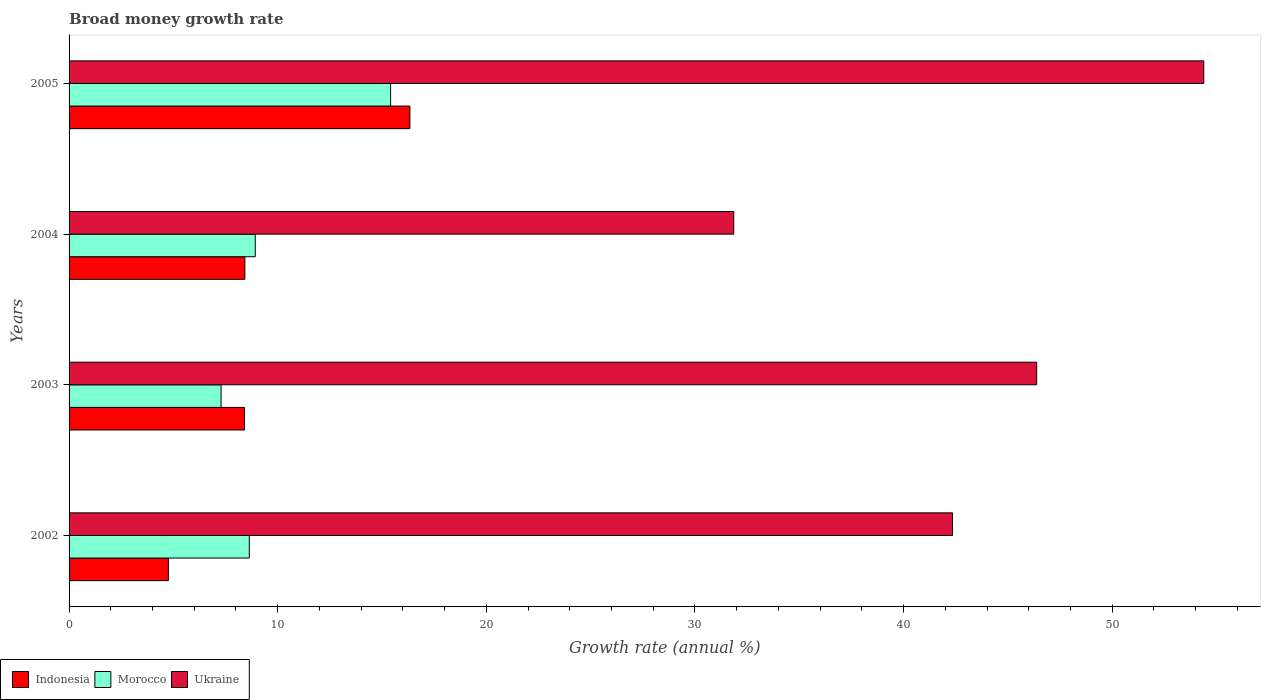Are the number of bars on each tick of the Y-axis equal?
Provide a short and direct response. Yes. What is the label of the 3rd group of bars from the top?
Offer a terse response. 2003. What is the growth rate in Ukraine in 2005?
Give a very brief answer. 54.39. Across all years, what is the maximum growth rate in Ukraine?
Keep it short and to the point. 54.39. Across all years, what is the minimum growth rate in Ukraine?
Your answer should be very brief. 31.86. In which year was the growth rate in Indonesia minimum?
Offer a terse response. 2002. What is the total growth rate in Indonesia in the graph?
Provide a succinct answer. 37.93. What is the difference between the growth rate in Morocco in 2003 and that in 2004?
Provide a succinct answer. -1.64. What is the difference between the growth rate in Morocco in 2004 and the growth rate in Indonesia in 2002?
Offer a very short reply. 4.16. What is the average growth rate in Ukraine per year?
Your answer should be very brief. 43.74. In the year 2002, what is the difference between the growth rate in Morocco and growth rate in Ukraine?
Provide a short and direct response. -33.7. In how many years, is the growth rate in Morocco greater than 30 %?
Offer a terse response. 0. What is the ratio of the growth rate in Indonesia in 2002 to that in 2003?
Provide a short and direct response. 0.57. What is the difference between the highest and the second highest growth rate in Indonesia?
Make the answer very short. 7.91. What is the difference between the highest and the lowest growth rate in Ukraine?
Offer a terse response. 22.53. What does the 1st bar from the top in 2004 represents?
Provide a succinct answer. Ukraine. What does the 1st bar from the bottom in 2002 represents?
Offer a very short reply. Indonesia. How many bars are there?
Make the answer very short. 12. Are all the bars in the graph horizontal?
Your response must be concise. Yes. What is the difference between two consecutive major ticks on the X-axis?
Provide a succinct answer. 10. Are the values on the major ticks of X-axis written in scientific E-notation?
Keep it short and to the point. No. Does the graph contain grids?
Your response must be concise. No. Where does the legend appear in the graph?
Ensure brevity in your answer.  Bottom left. How many legend labels are there?
Make the answer very short. 3. What is the title of the graph?
Ensure brevity in your answer.  Broad money growth rate. What is the label or title of the X-axis?
Give a very brief answer. Growth rate (annual %). What is the label or title of the Y-axis?
Ensure brevity in your answer.  Years. What is the Growth rate (annual %) of Indonesia in 2002?
Your response must be concise. 4.76. What is the Growth rate (annual %) in Morocco in 2002?
Your answer should be compact. 8.64. What is the Growth rate (annual %) in Ukraine in 2002?
Your response must be concise. 42.34. What is the Growth rate (annual %) in Indonesia in 2003?
Your answer should be compact. 8.41. What is the Growth rate (annual %) in Morocco in 2003?
Make the answer very short. 7.29. What is the Growth rate (annual %) of Ukraine in 2003?
Your answer should be compact. 46.38. What is the Growth rate (annual %) in Indonesia in 2004?
Offer a very short reply. 8.43. What is the Growth rate (annual %) of Morocco in 2004?
Give a very brief answer. 8.92. What is the Growth rate (annual %) in Ukraine in 2004?
Your response must be concise. 31.86. What is the Growth rate (annual %) in Indonesia in 2005?
Give a very brief answer. 16.34. What is the Growth rate (annual %) of Morocco in 2005?
Ensure brevity in your answer.  15.41. What is the Growth rate (annual %) in Ukraine in 2005?
Your response must be concise. 54.39. Across all years, what is the maximum Growth rate (annual %) in Indonesia?
Offer a terse response. 16.34. Across all years, what is the maximum Growth rate (annual %) in Morocco?
Provide a short and direct response. 15.41. Across all years, what is the maximum Growth rate (annual %) of Ukraine?
Provide a succinct answer. 54.39. Across all years, what is the minimum Growth rate (annual %) of Indonesia?
Give a very brief answer. 4.76. Across all years, what is the minimum Growth rate (annual %) in Morocco?
Your response must be concise. 7.29. Across all years, what is the minimum Growth rate (annual %) of Ukraine?
Give a very brief answer. 31.86. What is the total Growth rate (annual %) of Indonesia in the graph?
Your answer should be compact. 37.93. What is the total Growth rate (annual %) of Morocco in the graph?
Provide a succinct answer. 40.26. What is the total Growth rate (annual %) in Ukraine in the graph?
Ensure brevity in your answer.  174.96. What is the difference between the Growth rate (annual %) of Indonesia in 2002 and that in 2003?
Your answer should be very brief. -3.65. What is the difference between the Growth rate (annual %) in Morocco in 2002 and that in 2003?
Provide a succinct answer. 1.35. What is the difference between the Growth rate (annual %) in Ukraine in 2002 and that in 2003?
Your answer should be very brief. -4.04. What is the difference between the Growth rate (annual %) of Indonesia in 2002 and that in 2004?
Make the answer very short. -3.66. What is the difference between the Growth rate (annual %) in Morocco in 2002 and that in 2004?
Your answer should be very brief. -0.29. What is the difference between the Growth rate (annual %) in Ukraine in 2002 and that in 2004?
Ensure brevity in your answer.  10.48. What is the difference between the Growth rate (annual %) of Indonesia in 2002 and that in 2005?
Your answer should be very brief. -11.57. What is the difference between the Growth rate (annual %) in Morocco in 2002 and that in 2005?
Provide a short and direct response. -6.77. What is the difference between the Growth rate (annual %) of Ukraine in 2002 and that in 2005?
Make the answer very short. -12.04. What is the difference between the Growth rate (annual %) in Indonesia in 2003 and that in 2004?
Ensure brevity in your answer.  -0.02. What is the difference between the Growth rate (annual %) in Morocco in 2003 and that in 2004?
Your answer should be very brief. -1.64. What is the difference between the Growth rate (annual %) in Ukraine in 2003 and that in 2004?
Give a very brief answer. 14.52. What is the difference between the Growth rate (annual %) of Indonesia in 2003 and that in 2005?
Keep it short and to the point. -7.93. What is the difference between the Growth rate (annual %) in Morocco in 2003 and that in 2005?
Give a very brief answer. -8.12. What is the difference between the Growth rate (annual %) in Ukraine in 2003 and that in 2005?
Ensure brevity in your answer.  -8.01. What is the difference between the Growth rate (annual %) of Indonesia in 2004 and that in 2005?
Ensure brevity in your answer.  -7.91. What is the difference between the Growth rate (annual %) in Morocco in 2004 and that in 2005?
Your answer should be compact. -6.49. What is the difference between the Growth rate (annual %) of Ukraine in 2004 and that in 2005?
Make the answer very short. -22.53. What is the difference between the Growth rate (annual %) in Indonesia in 2002 and the Growth rate (annual %) in Morocco in 2003?
Keep it short and to the point. -2.52. What is the difference between the Growth rate (annual %) in Indonesia in 2002 and the Growth rate (annual %) in Ukraine in 2003?
Your response must be concise. -41.62. What is the difference between the Growth rate (annual %) of Morocco in 2002 and the Growth rate (annual %) of Ukraine in 2003?
Your response must be concise. -37.74. What is the difference between the Growth rate (annual %) of Indonesia in 2002 and the Growth rate (annual %) of Morocco in 2004?
Your response must be concise. -4.16. What is the difference between the Growth rate (annual %) in Indonesia in 2002 and the Growth rate (annual %) in Ukraine in 2004?
Give a very brief answer. -27.1. What is the difference between the Growth rate (annual %) of Morocco in 2002 and the Growth rate (annual %) of Ukraine in 2004?
Ensure brevity in your answer.  -23.22. What is the difference between the Growth rate (annual %) of Indonesia in 2002 and the Growth rate (annual %) of Morocco in 2005?
Provide a short and direct response. -10.65. What is the difference between the Growth rate (annual %) of Indonesia in 2002 and the Growth rate (annual %) of Ukraine in 2005?
Provide a succinct answer. -49.62. What is the difference between the Growth rate (annual %) of Morocco in 2002 and the Growth rate (annual %) of Ukraine in 2005?
Make the answer very short. -45.75. What is the difference between the Growth rate (annual %) in Indonesia in 2003 and the Growth rate (annual %) in Morocco in 2004?
Provide a succinct answer. -0.51. What is the difference between the Growth rate (annual %) in Indonesia in 2003 and the Growth rate (annual %) in Ukraine in 2004?
Give a very brief answer. -23.45. What is the difference between the Growth rate (annual %) of Morocco in 2003 and the Growth rate (annual %) of Ukraine in 2004?
Offer a very short reply. -24.57. What is the difference between the Growth rate (annual %) of Indonesia in 2003 and the Growth rate (annual %) of Morocco in 2005?
Keep it short and to the point. -7. What is the difference between the Growth rate (annual %) in Indonesia in 2003 and the Growth rate (annual %) in Ukraine in 2005?
Offer a very short reply. -45.98. What is the difference between the Growth rate (annual %) of Morocco in 2003 and the Growth rate (annual %) of Ukraine in 2005?
Your answer should be very brief. -47.1. What is the difference between the Growth rate (annual %) in Indonesia in 2004 and the Growth rate (annual %) in Morocco in 2005?
Provide a short and direct response. -6.98. What is the difference between the Growth rate (annual %) in Indonesia in 2004 and the Growth rate (annual %) in Ukraine in 2005?
Provide a short and direct response. -45.96. What is the difference between the Growth rate (annual %) of Morocco in 2004 and the Growth rate (annual %) of Ukraine in 2005?
Provide a short and direct response. -45.46. What is the average Growth rate (annual %) in Indonesia per year?
Your answer should be very brief. 9.48. What is the average Growth rate (annual %) of Morocco per year?
Make the answer very short. 10.06. What is the average Growth rate (annual %) in Ukraine per year?
Your answer should be compact. 43.74. In the year 2002, what is the difference between the Growth rate (annual %) in Indonesia and Growth rate (annual %) in Morocco?
Keep it short and to the point. -3.88. In the year 2002, what is the difference between the Growth rate (annual %) of Indonesia and Growth rate (annual %) of Ukraine?
Your response must be concise. -37.58. In the year 2002, what is the difference between the Growth rate (annual %) of Morocco and Growth rate (annual %) of Ukraine?
Keep it short and to the point. -33.7. In the year 2003, what is the difference between the Growth rate (annual %) of Indonesia and Growth rate (annual %) of Morocco?
Your answer should be compact. 1.12. In the year 2003, what is the difference between the Growth rate (annual %) of Indonesia and Growth rate (annual %) of Ukraine?
Ensure brevity in your answer.  -37.97. In the year 2003, what is the difference between the Growth rate (annual %) of Morocco and Growth rate (annual %) of Ukraine?
Your answer should be very brief. -39.09. In the year 2004, what is the difference between the Growth rate (annual %) in Indonesia and Growth rate (annual %) in Morocco?
Your response must be concise. -0.5. In the year 2004, what is the difference between the Growth rate (annual %) in Indonesia and Growth rate (annual %) in Ukraine?
Provide a succinct answer. -23.43. In the year 2004, what is the difference between the Growth rate (annual %) in Morocco and Growth rate (annual %) in Ukraine?
Make the answer very short. -22.93. In the year 2005, what is the difference between the Growth rate (annual %) in Indonesia and Growth rate (annual %) in Morocco?
Ensure brevity in your answer.  0.92. In the year 2005, what is the difference between the Growth rate (annual %) of Indonesia and Growth rate (annual %) of Ukraine?
Offer a terse response. -38.05. In the year 2005, what is the difference between the Growth rate (annual %) of Morocco and Growth rate (annual %) of Ukraine?
Give a very brief answer. -38.98. What is the ratio of the Growth rate (annual %) of Indonesia in 2002 to that in 2003?
Ensure brevity in your answer.  0.57. What is the ratio of the Growth rate (annual %) of Morocco in 2002 to that in 2003?
Your answer should be very brief. 1.19. What is the ratio of the Growth rate (annual %) in Ukraine in 2002 to that in 2003?
Ensure brevity in your answer.  0.91. What is the ratio of the Growth rate (annual %) in Indonesia in 2002 to that in 2004?
Provide a succinct answer. 0.57. What is the ratio of the Growth rate (annual %) in Morocco in 2002 to that in 2004?
Ensure brevity in your answer.  0.97. What is the ratio of the Growth rate (annual %) of Ukraine in 2002 to that in 2004?
Your response must be concise. 1.33. What is the ratio of the Growth rate (annual %) of Indonesia in 2002 to that in 2005?
Offer a terse response. 0.29. What is the ratio of the Growth rate (annual %) in Morocco in 2002 to that in 2005?
Provide a succinct answer. 0.56. What is the ratio of the Growth rate (annual %) in Ukraine in 2002 to that in 2005?
Keep it short and to the point. 0.78. What is the ratio of the Growth rate (annual %) in Morocco in 2003 to that in 2004?
Your answer should be very brief. 0.82. What is the ratio of the Growth rate (annual %) in Ukraine in 2003 to that in 2004?
Provide a short and direct response. 1.46. What is the ratio of the Growth rate (annual %) of Indonesia in 2003 to that in 2005?
Your answer should be very brief. 0.51. What is the ratio of the Growth rate (annual %) in Morocco in 2003 to that in 2005?
Your answer should be very brief. 0.47. What is the ratio of the Growth rate (annual %) in Ukraine in 2003 to that in 2005?
Make the answer very short. 0.85. What is the ratio of the Growth rate (annual %) of Indonesia in 2004 to that in 2005?
Make the answer very short. 0.52. What is the ratio of the Growth rate (annual %) in Morocco in 2004 to that in 2005?
Your response must be concise. 0.58. What is the ratio of the Growth rate (annual %) in Ukraine in 2004 to that in 2005?
Your response must be concise. 0.59. What is the difference between the highest and the second highest Growth rate (annual %) of Indonesia?
Ensure brevity in your answer.  7.91. What is the difference between the highest and the second highest Growth rate (annual %) of Morocco?
Ensure brevity in your answer.  6.49. What is the difference between the highest and the second highest Growth rate (annual %) of Ukraine?
Ensure brevity in your answer.  8.01. What is the difference between the highest and the lowest Growth rate (annual %) of Indonesia?
Offer a terse response. 11.57. What is the difference between the highest and the lowest Growth rate (annual %) in Morocco?
Offer a very short reply. 8.12. What is the difference between the highest and the lowest Growth rate (annual %) in Ukraine?
Your answer should be compact. 22.53. 